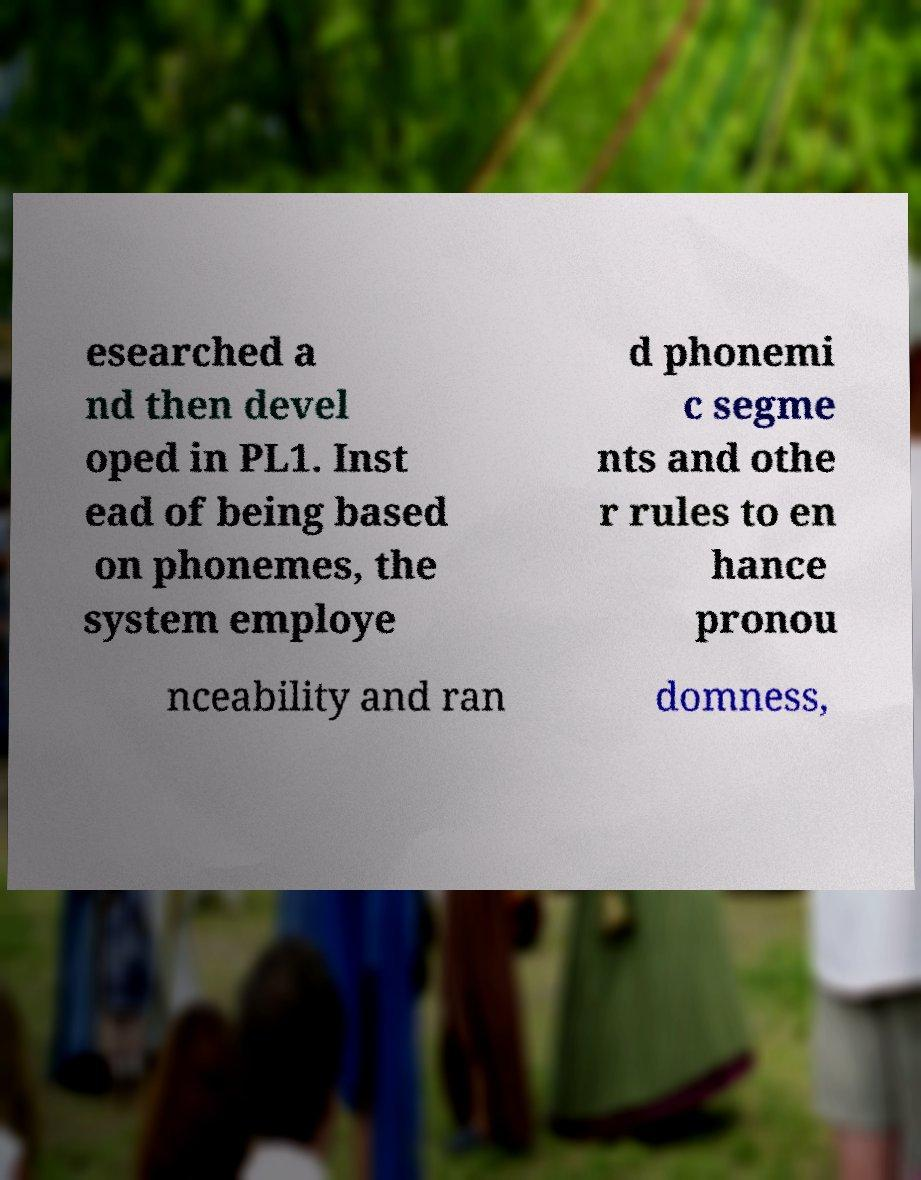Please identify and transcribe the text found in this image. esearched a nd then devel oped in PL1. Inst ead of being based on phonemes, the system employe d phonemi c segme nts and othe r rules to en hance pronou nceability and ran domness, 